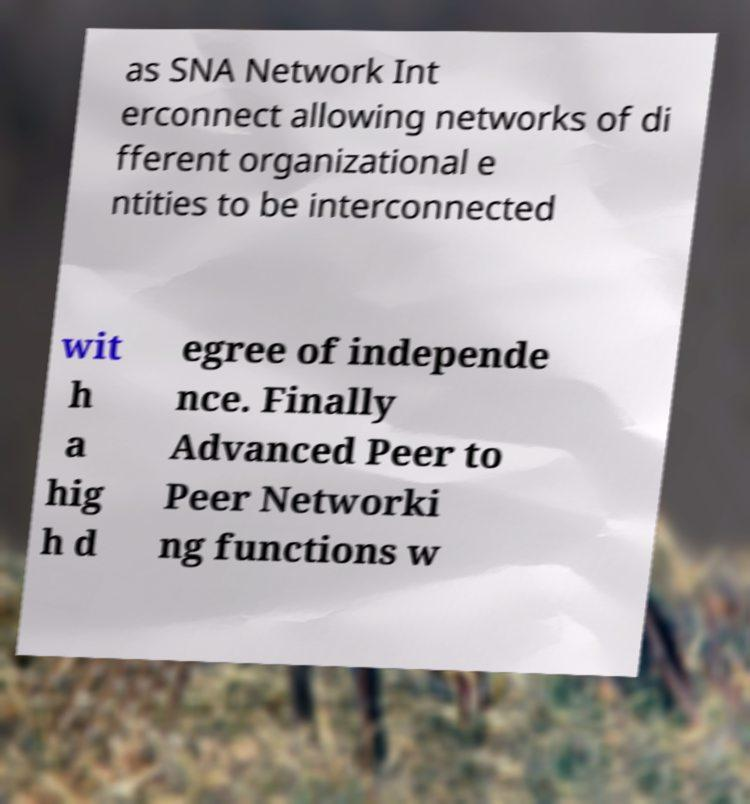Can you accurately transcribe the text from the provided image for me? as SNA Network Int erconnect allowing networks of di fferent organizational e ntities to be interconnected wit h a hig h d egree of independe nce. Finally Advanced Peer to Peer Networki ng functions w 